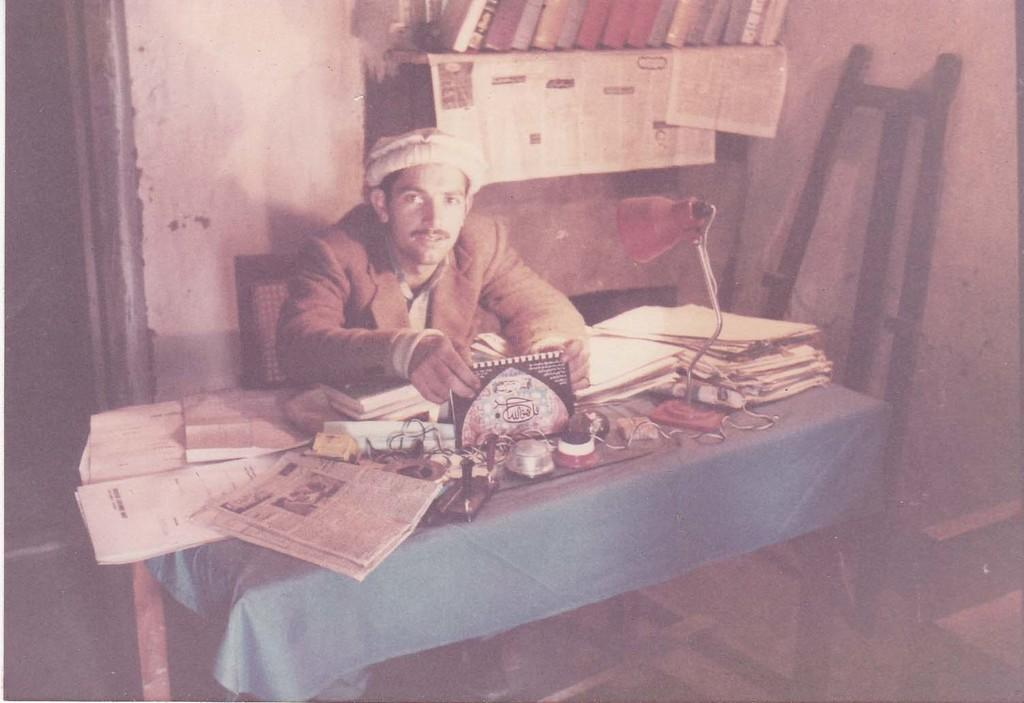What is the man in the image holding? The man is holding a book. What is the man's position in the image? The man is sitting on a chair. What objects can be seen in the image besides the man? There is a lamp, a file, and a newspaper in the image. What piece of furniture is present in the image? There is a table in the image. What type of apparel is the man wearing to stop the car in the image? There is no car or brake present in the image, and the man is not wearing any apparel related to stopping a car. 